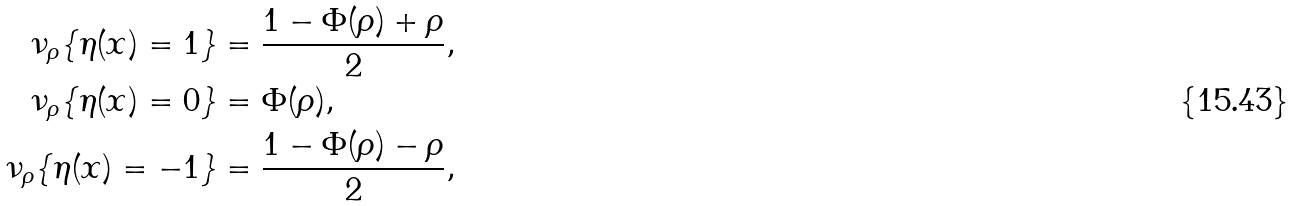Convert formula to latex. <formula><loc_0><loc_0><loc_500><loc_500>\nu _ { \rho } \{ \eta ( x ) = 1 \} & = \frac { 1 - \Phi ( \rho ) + \rho } { 2 } , \\ \nu _ { \rho } \{ \eta ( x ) = 0 \} & = \Phi ( \rho ) , \\ \nu _ { \rho } \{ \eta ( x ) = - 1 \} & = \frac { 1 - \Phi ( \rho ) - \rho } { 2 } ,</formula> 